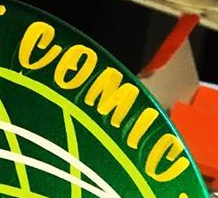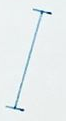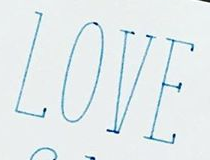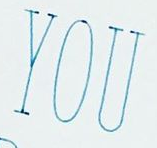What words are shown in these images in order, separated by a semicolon? COMIC; I; LOVE; YOU 